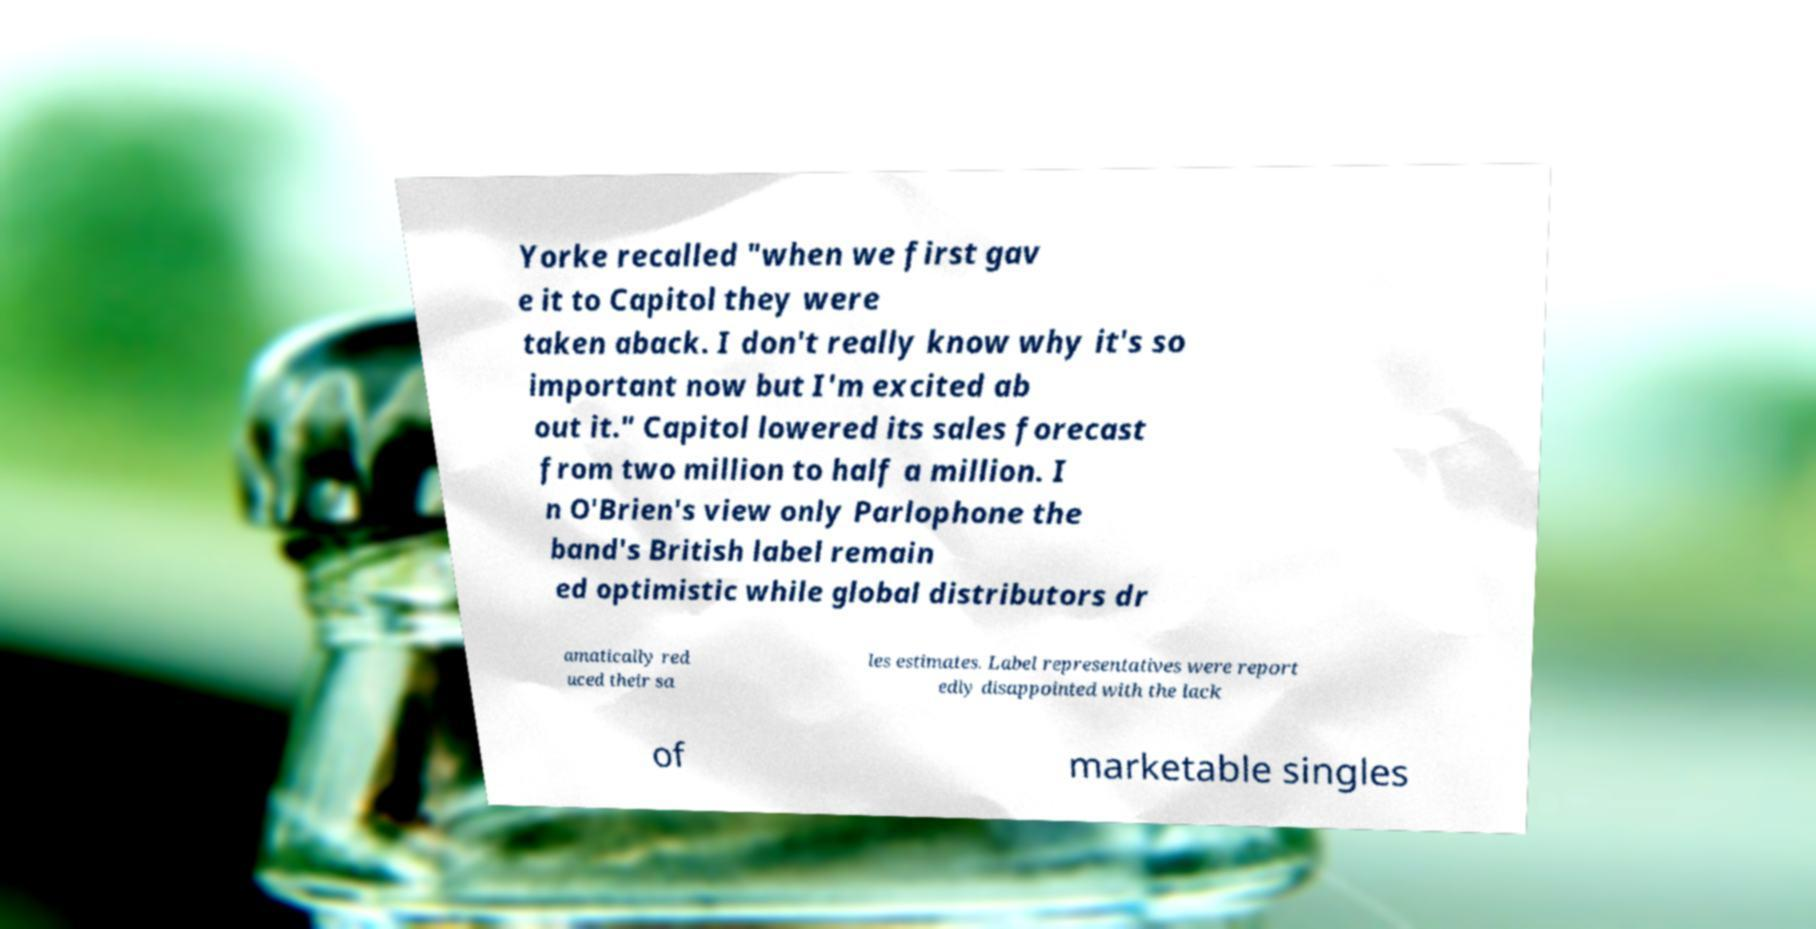There's text embedded in this image that I need extracted. Can you transcribe it verbatim? Yorke recalled "when we first gav e it to Capitol they were taken aback. I don't really know why it's so important now but I'm excited ab out it." Capitol lowered its sales forecast from two million to half a million. I n O'Brien's view only Parlophone the band's British label remain ed optimistic while global distributors dr amatically red uced their sa les estimates. Label representatives were report edly disappointed with the lack of marketable singles 